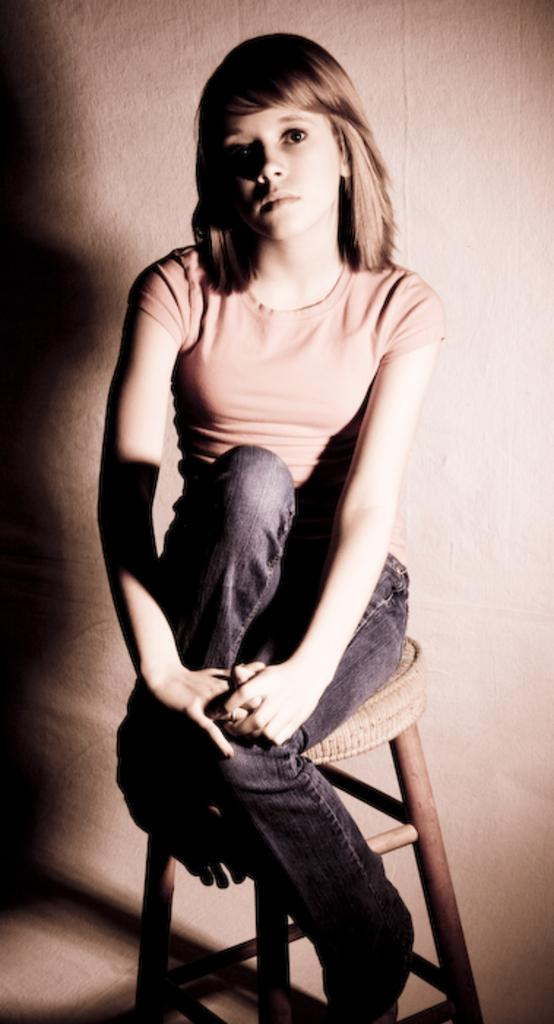Who is the main subject in the image? There is a girl in the image. What is the girl wearing? The girl is wearing clothes. What is the girl sitting on? The girl is sitting on a stool. Is the stool visible in the image? Yes, the stool is present in the image. What can be seen behind the girl? There is a wall in the image. Is the girl playing basketball in the image? No, the girl is not playing basketball in the image. There is no basketball present in the image. 